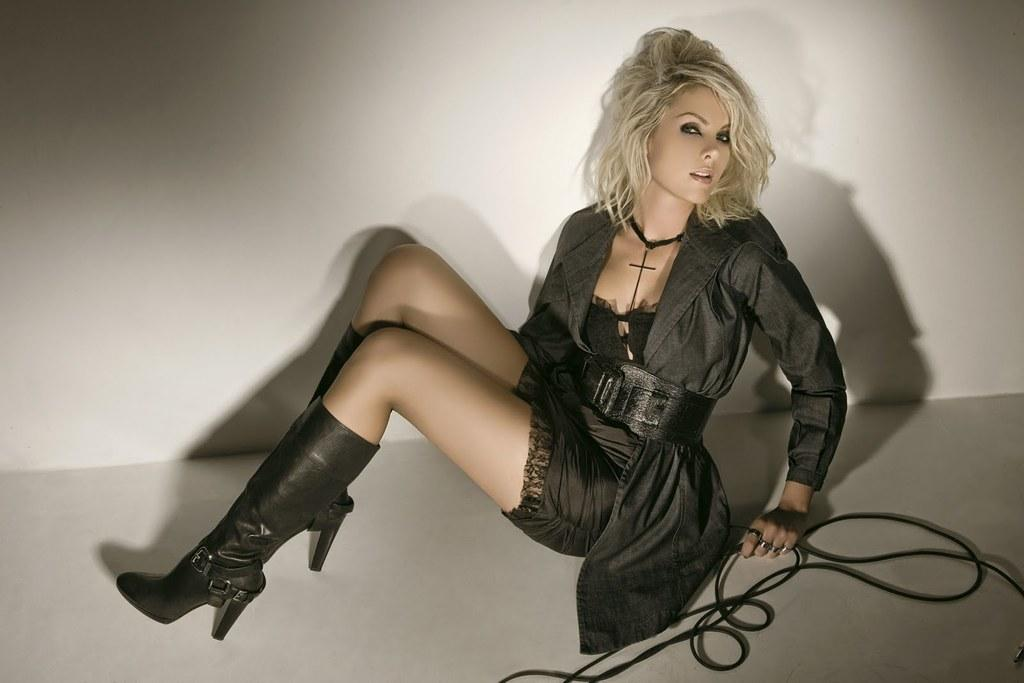Who is the main subject in the image? There is a lady in the image. What is the lady doing in the image? The lady is sitting on the floor. What is the lady holding in her hand? The lady is holding a black color rope in her hand. What type of footwear is the lady wearing? The lady is wearing boots. How many toes can be seen on the hen in the image? There is no hen present in the image, so the number of toes cannot be determined. 